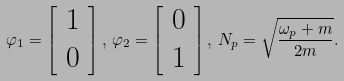Convert formula to latex. <formula><loc_0><loc_0><loc_500><loc_500>\varphi _ { 1 } = \left [ \begin{array} { c } 1 \\ 0 \end{array} \right ] , \, \varphi _ { 2 } = \left [ \begin{array} { c } 0 \\ 1 \end{array} \right ] , \, N _ { p } = \sqrt { \frac { \omega _ { p } + m } { 2 m } } .</formula> 